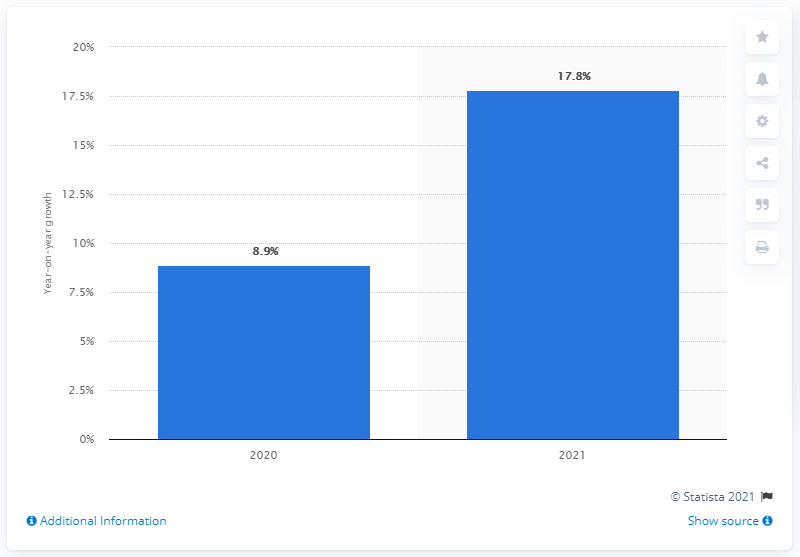Outline some significant characteristics in this image. In 2021, the projected growth rate for cloud telephony is expected to be 17.8%. 